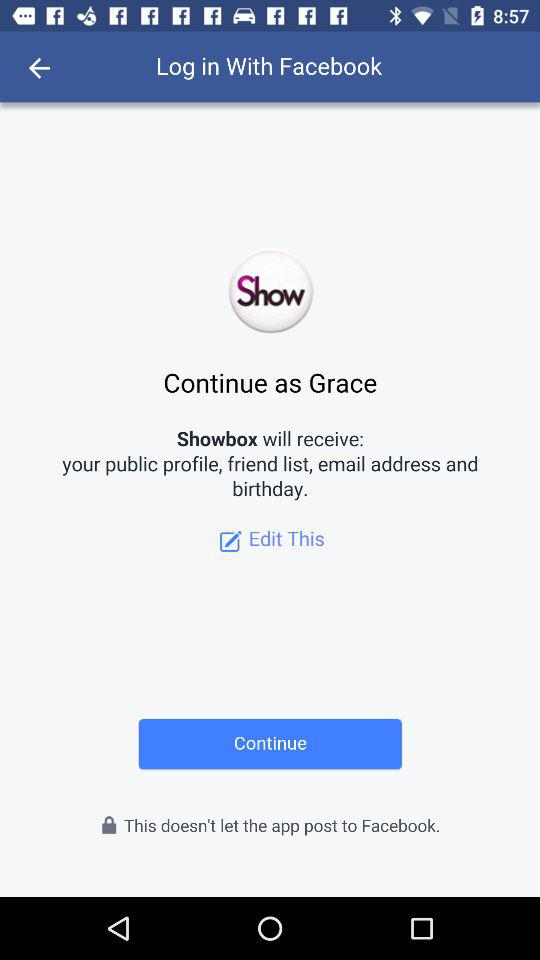What application is asking for permission? The application "Showbox" is asking for permission. 